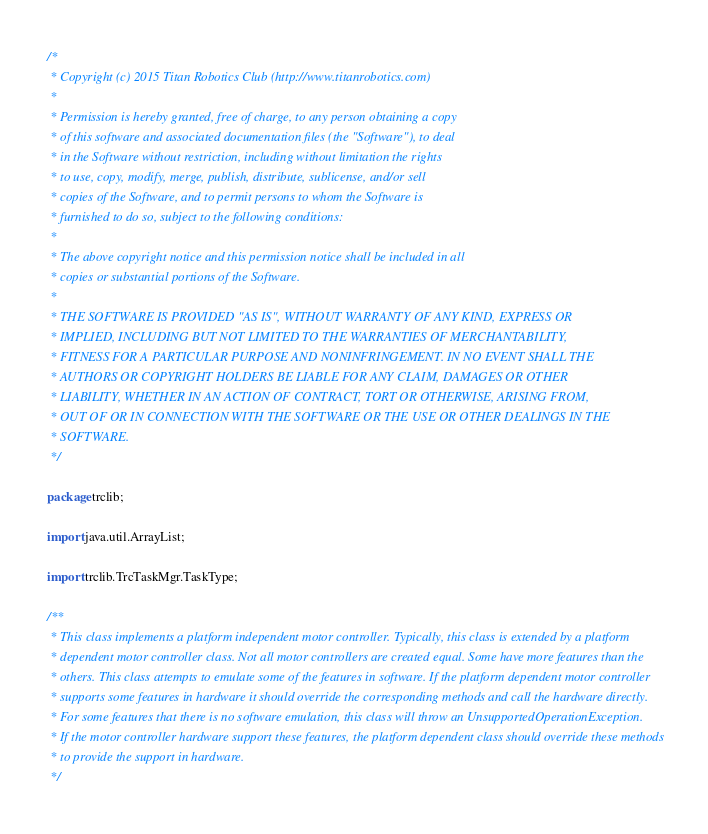<code> <loc_0><loc_0><loc_500><loc_500><_Java_>/*
 * Copyright (c) 2015 Titan Robotics Club (http://www.titanrobotics.com)
 *
 * Permission is hereby granted, free of charge, to any person obtaining a copy
 * of this software and associated documentation files (the "Software"), to deal
 * in the Software without restriction, including without limitation the rights
 * to use, copy, modify, merge, publish, distribute, sublicense, and/or sell
 * copies of the Software, and to permit persons to whom the Software is
 * furnished to do so, subject to the following conditions:
 *
 * The above copyright notice and this permission notice shall be included in all
 * copies or substantial portions of the Software.
 *
 * THE SOFTWARE IS PROVIDED "AS IS", WITHOUT WARRANTY OF ANY KIND, EXPRESS OR
 * IMPLIED, INCLUDING BUT NOT LIMITED TO THE WARRANTIES OF MERCHANTABILITY,
 * FITNESS FOR A PARTICULAR PURPOSE AND NONINFRINGEMENT. IN NO EVENT SHALL THE
 * AUTHORS OR COPYRIGHT HOLDERS BE LIABLE FOR ANY CLAIM, DAMAGES OR OTHER
 * LIABILITY, WHETHER IN AN ACTION OF CONTRACT, TORT OR OTHERWISE, ARISING FROM,
 * OUT OF OR IN CONNECTION WITH THE SOFTWARE OR THE USE OR OTHER DEALINGS IN THE
 * SOFTWARE.
 */

package trclib;

import java.util.ArrayList;

import trclib.TrcTaskMgr.TaskType;

/**
 * This class implements a platform independent motor controller. Typically, this class is extended by a platform
 * dependent motor controller class. Not all motor controllers are created equal. Some have more features than the
 * others. This class attempts to emulate some of the features in software. If the platform dependent motor controller
 * supports some features in hardware it should override the corresponding methods and call the hardware directly.
 * For some features that there is no software emulation, this class will throw an UnsupportedOperationException.
 * If the motor controller hardware support these features, the platform dependent class should override these methods
 * to provide the support in hardware.
 */</code> 